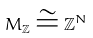Convert formula to latex. <formula><loc_0><loc_0><loc_500><loc_500>M _ { \mathbb { Z } } \cong \mathbb { Z } ^ { N }</formula> 